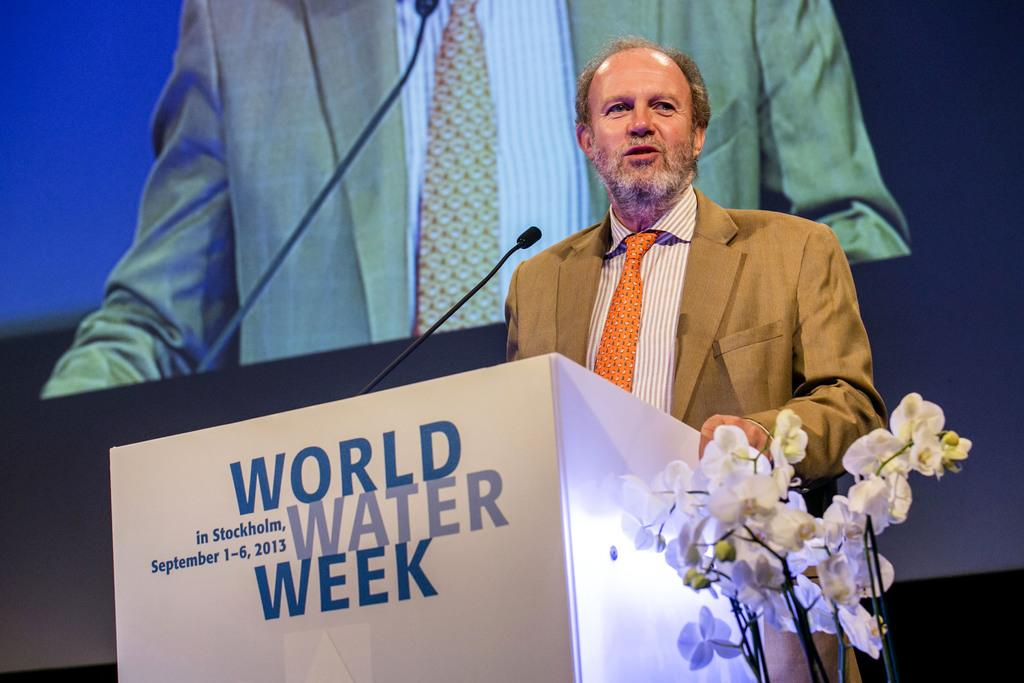What is the man in the image doing? The man is standing in the image. Where is the man located in relation to other objects in the image? The man is standing in front of a desk. What can be seen in the foreground of the image? A microphone is present in the foreground area of the image. What is visible in the background of the image? There are flowers and a screen in the background of the image. What type of chalk is the man using to draw on the pan in the image? There is no chalk or pan present in the image. 